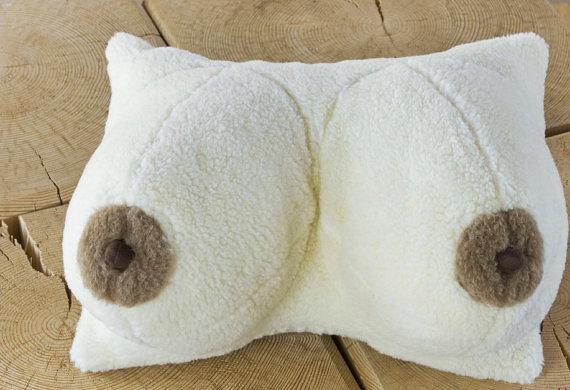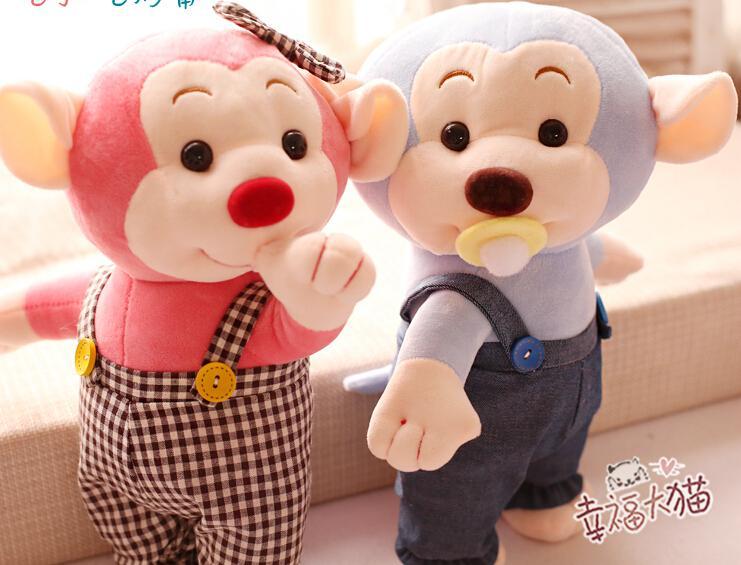The first image is the image on the left, the second image is the image on the right. Given the left and right images, does the statement "There is a single white pillow with a pair of breasts on them." hold true? Answer yes or no. Yes. 